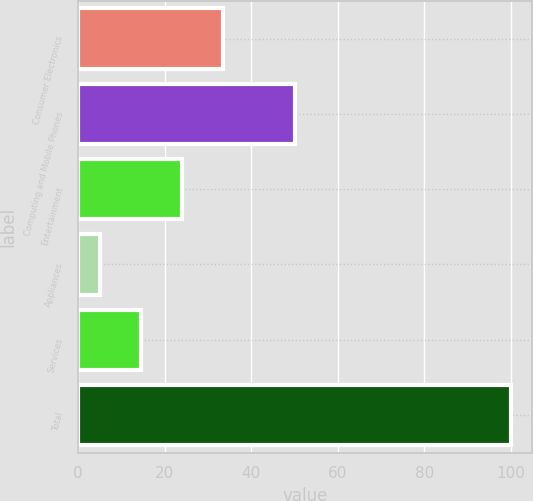Convert chart. <chart><loc_0><loc_0><loc_500><loc_500><bar_chart><fcel>Consumer Electronics<fcel>Computing and Mobile Phones<fcel>Entertainment<fcel>Appliances<fcel>Services<fcel>Total<nl><fcel>33.5<fcel>50<fcel>24<fcel>5<fcel>14.5<fcel>100<nl></chart> 